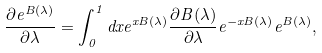Convert formula to latex. <formula><loc_0><loc_0><loc_500><loc_500>\frac { \partial e ^ { B ( \lambda ) } } { \partial \lambda } = \int ^ { 1 } _ { 0 } d x e ^ { x B ( \lambda ) } \frac { \partial B ( \lambda ) } { \partial \lambda } e ^ { - x B ( \lambda ) } e ^ { B ( \lambda ) } ,</formula> 